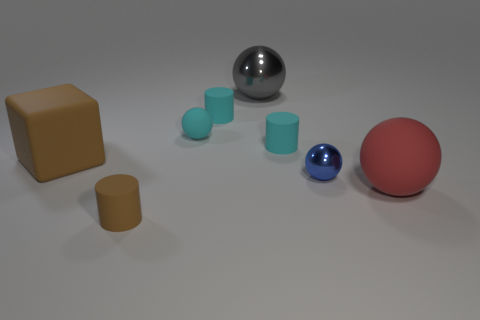Subtract 1 spheres. How many spheres are left? 3 Subtract all gray cylinders. Subtract all gray balls. How many cylinders are left? 3 Add 1 small gray metal cylinders. How many objects exist? 9 Subtract all blocks. How many objects are left? 7 Add 4 metal balls. How many metal balls exist? 6 Subtract 0 purple blocks. How many objects are left? 8 Subtract all big gray metal objects. Subtract all balls. How many objects are left? 3 Add 1 brown objects. How many brown objects are left? 3 